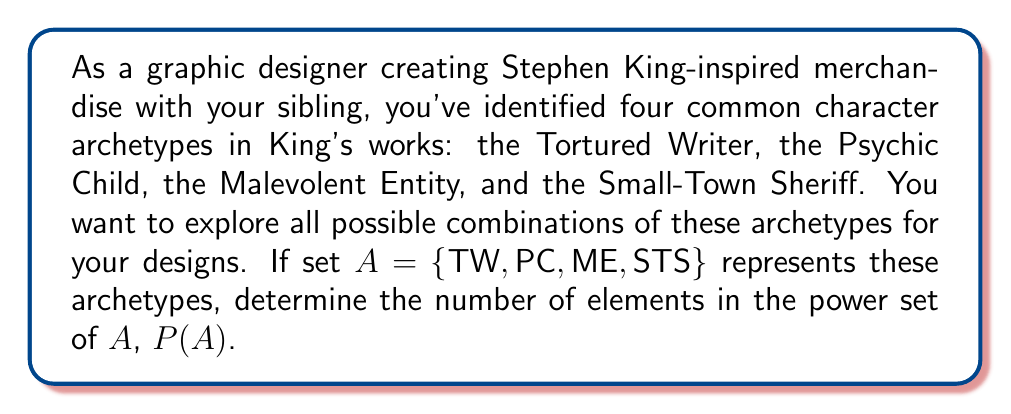Can you solve this math problem? To solve this problem, let's follow these steps:

1) First, recall that the power set of a set $A$ is the set of all subsets of $A$, including the empty set and $A$ itself.

2) The number of elements in a power set is given by the formula:

   $$ |P(A)| = 2^n $$

   where $n$ is the number of elements in the original set $A$.

3) In this case, set $A$ contains 4 elements:
   $A = \{TW, PC, ME, STS\}$
   So, $n = 4$

4) Applying the formula:

   $$ |P(A)| = 2^4 = 16 $$

5) To verify this result, we can list all possible subsets:
   - Empty set: $\{\}$
   - Single element sets: $\{TW\}$, $\{PC\}$, $\{ME\}$, $\{STS\}$
   - Two element sets: $\{TW,PC\}$, $\{TW,ME\}$, $\{TW,STS\}$, $\{PC,ME\}$, $\{PC,STS\}$, $\{ME,STS\}$
   - Three element sets: $\{TW,PC,ME\}$, $\{TW,PC,STS\}$, $\{TW,ME,STS\}$, $\{PC,ME,STS\}$
   - Full set: $\{TW,PC,ME,STS\}$

   Indeed, there are 16 subsets in total.

This means you have 16 different combinations of archetypes to consider for your Stephen King-inspired merchandise designs, ranging from using no archetypes at all to using all four simultaneously.
Answer: $|P(A)| = 16$ 